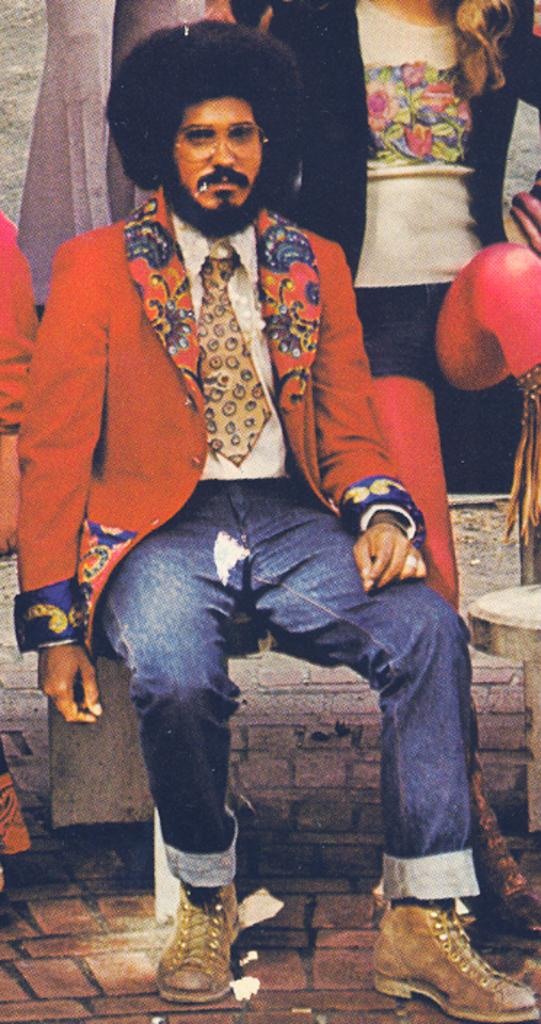Who is present in the image? There is a person in the image. What can be observed about the person's appearance? The person is wearing specs. What is the person doing in the image? The person is sitting on a chair. Can you describe the surroundings in the image? There are other persons visible in the background of the image. What type of pies are being served by the robin in the image? There is no robin or pies present in the image. 